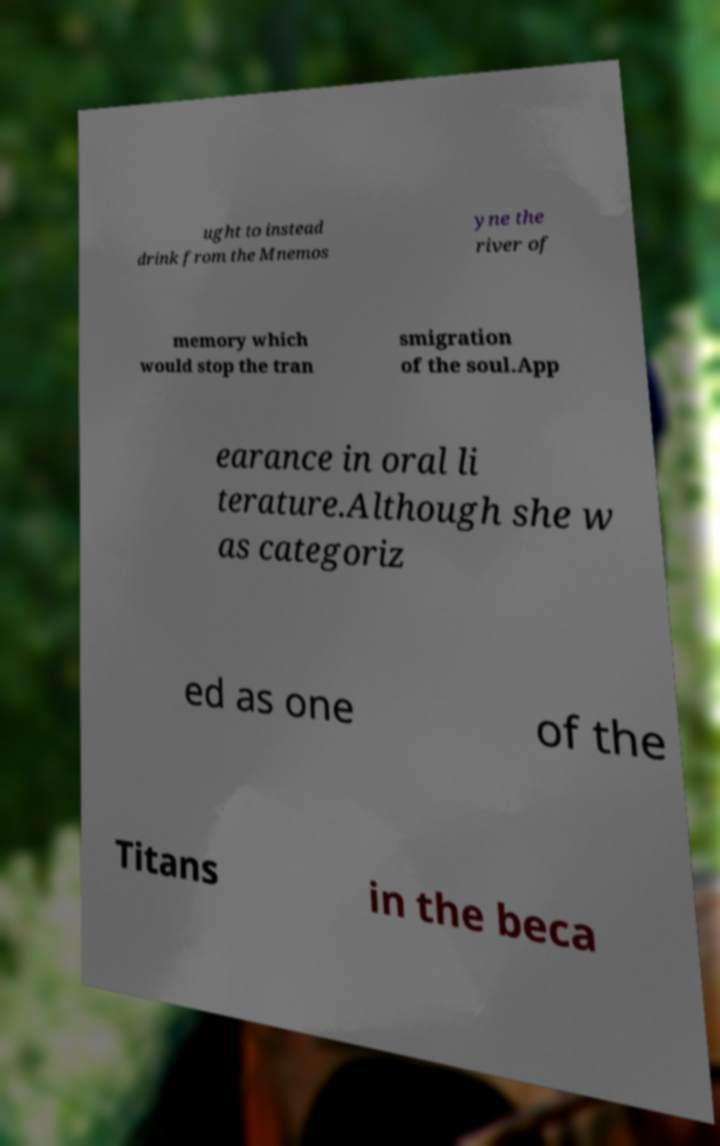I need the written content from this picture converted into text. Can you do that? ught to instead drink from the Mnemos yne the river of memory which would stop the tran smigration of the soul.App earance in oral li terature.Although she w as categoriz ed as one of the Titans in the beca 